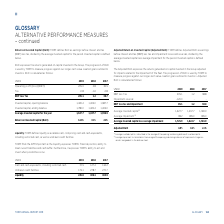According to Torm's financial document, How does TORM define liquidity? Based on the financial document, the answer is TORM defines liquidity as available cash, comprising cash and cash equivalents, including restricted cash, as well as undrawn credit facilities. Also, Why does TORM find the APM important? as the liquidity expresses TORM’s financial position, ability to meet current liabilities and cash buffer. Furthermore, it expresses TORM’s ability to act and invest when possibilities occur.. The document states: "wn credit facilities. TORM finds the APM important as the liquidity expresses TORM’s financial position, ability to meet current liabilities and cash ..." Also, What are the components in the table used to calculate liquidity? The document shows two values: Cash and cash equivalents, including restricted cash and Undrawn credit facilities. From the document: "Undrawn credit facilities 173.1 278.7 270.7 Cash and cash equivalents, including restricted cash 72.5 127.4 134.2..." Additionally, In which year was liquidity the largest? According to the financial document, 2018. The relevant text states: "USDm 2019 2018 2017..." Also, can you calculate: What was the change in liquidity in 2019 from 2018? Based on the calculation: 245.6-406.1, the result is -160.5 (in millions). This is based on the information: "Liquidity 245.6 406.1 404.9 Liquidity 245.6 406.1 404.9..." The key data points involved are: 245.6, 406.1. Also, can you calculate: What was the percentage change in liquidity in 2019 from 2018? To answer this question, I need to perform calculations using the financial data. The calculation is: (245.6-406.1)/406.1, which equals -39.52 (percentage). This is based on the information: "Liquidity 245.6 406.1 404.9 Liquidity 245.6 406.1 404.9..." The key data points involved are: 245.6, 406.1. 